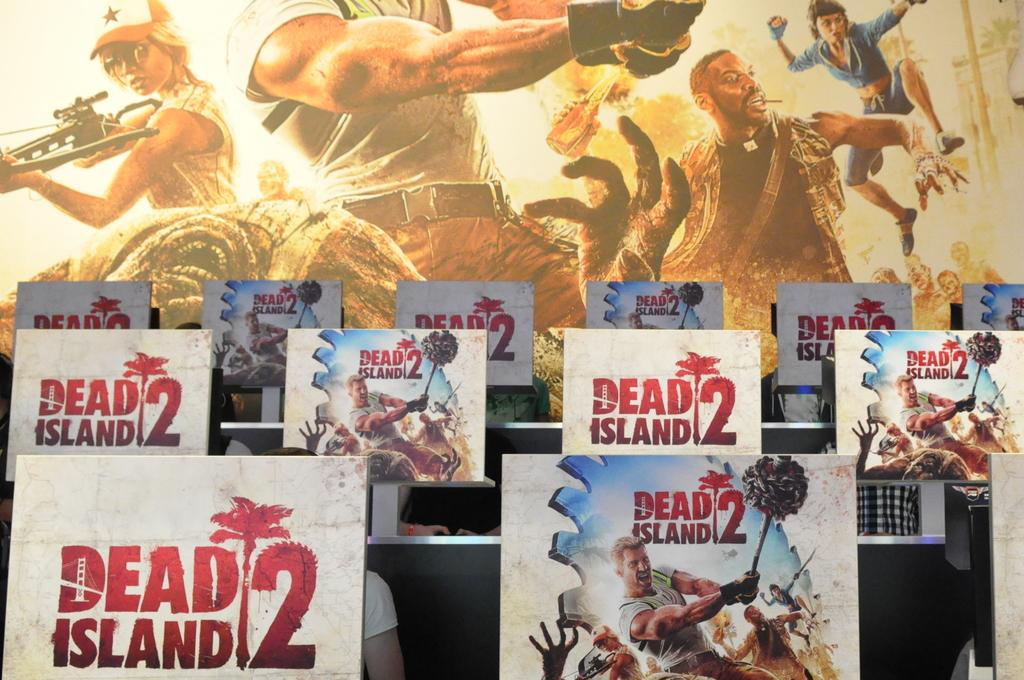What objects are located at the bottom of the image? There are boards present at the bottom of the image. What can be seen at the top of the image? There is a screen with a cartoon picture at the top of the image. How much profit does the spring in the image generate? There is no spring present in the image, so it is not possible to determine any profit generated. 